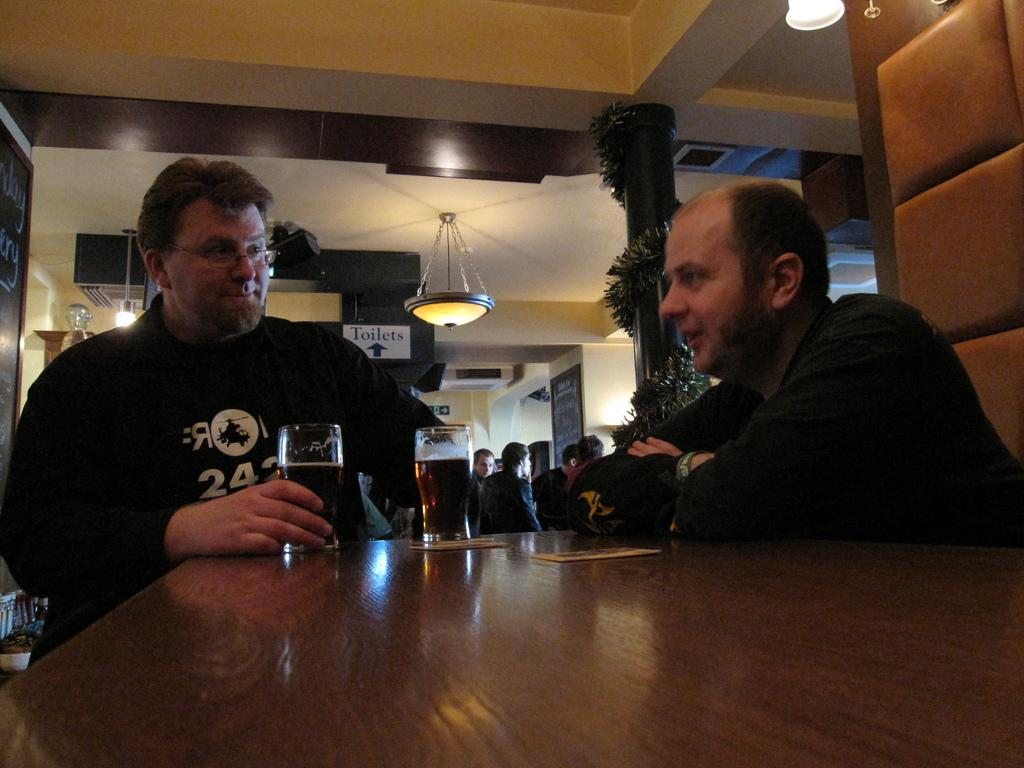How many men are in the image? There are two men in the image. What are the men wearing? The men are wearing glasses. What is on the table in front of the men? There are glasses of beer on the table in front of the men. What is the main piece of furniture in the image? There is a table in the image. Can you describe the people behind the men? There is a group of people standing behind the men. How does the boat contribute to the pollution in the image? There is no boat present in the image, so it cannot contribute to any pollution. 